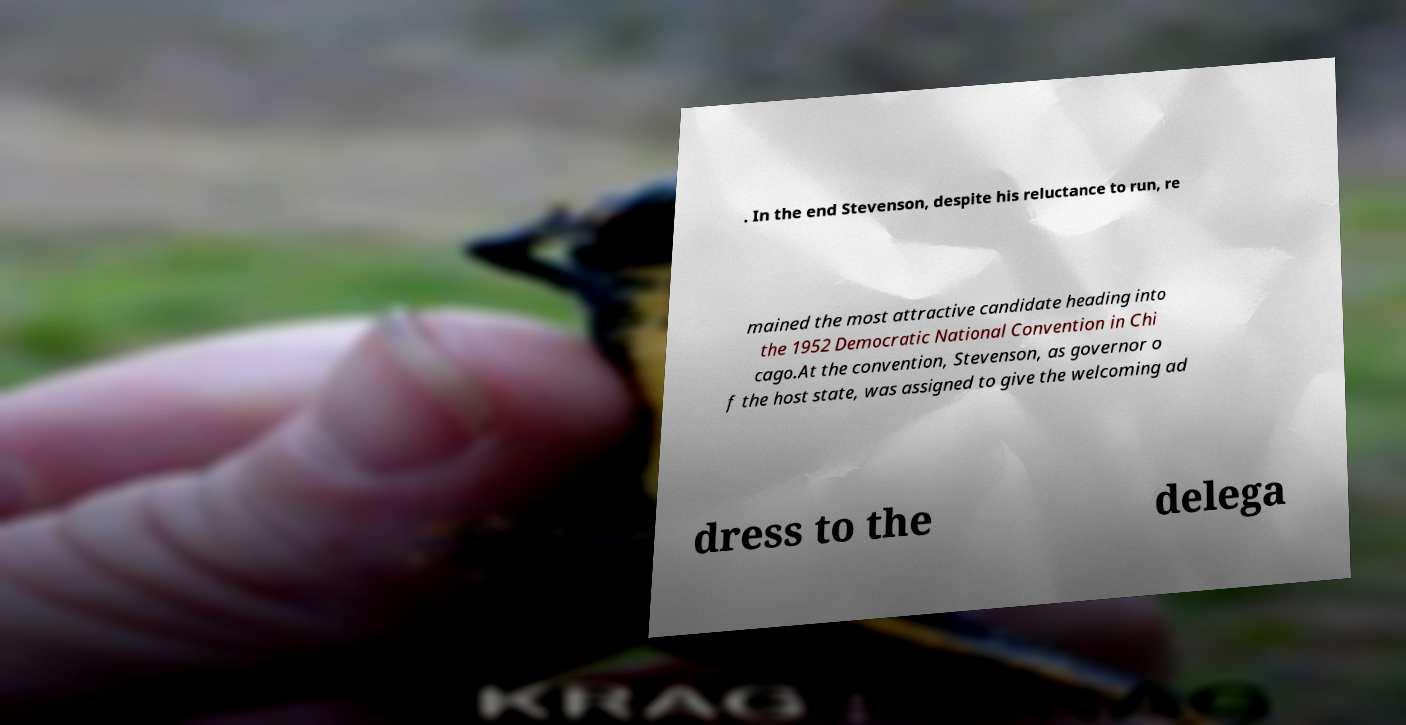Please read and relay the text visible in this image. What does it say? . In the end Stevenson, despite his reluctance to run, re mained the most attractive candidate heading into the 1952 Democratic National Convention in Chi cago.At the convention, Stevenson, as governor o f the host state, was assigned to give the welcoming ad dress to the delega 